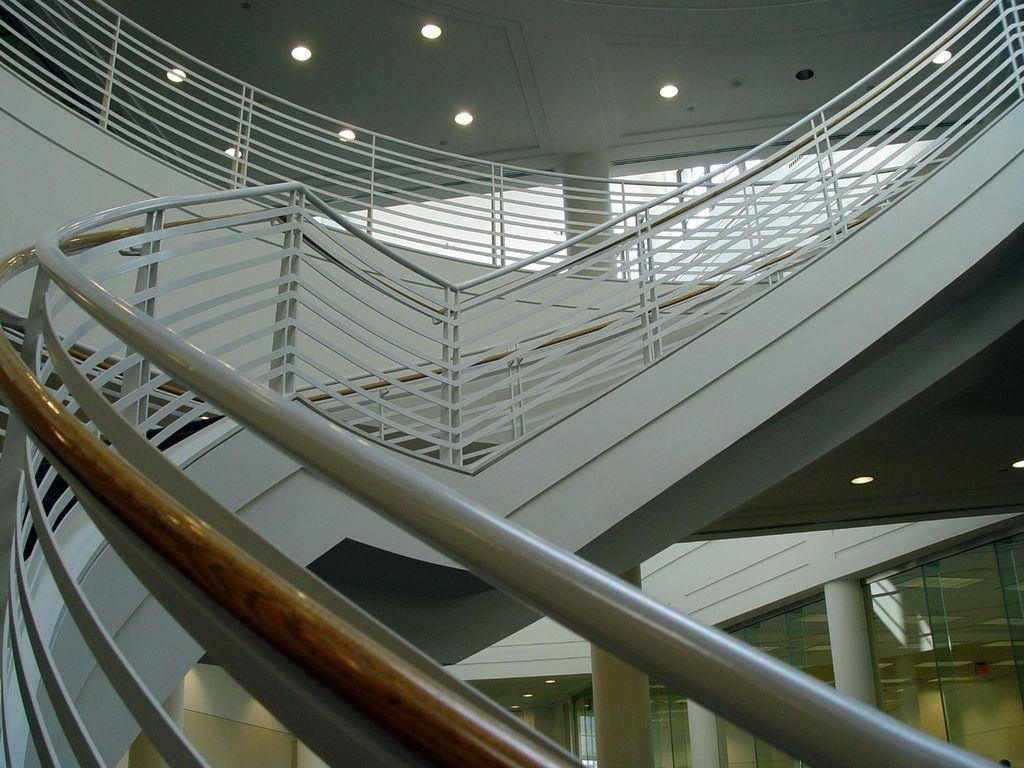What type of view is shown in the image? The image shows an inner view of a building. What can be seen on the ceiling of the building? There is a roof with lights in the image. What architectural elements support the structure in the image? Pillars are present in the image. What safety feature is visible in the image? There is a railing in the image. What type of wall is visible in the image? The glass wall is visible in the image. What type of yarn is being used in the image? There is no yarn present in the image. --- Facts: 1. There is a person in the image. 2. The person is wearing a hat. 3. The person is holding a book. 4. The person is sitting on a chair. 5. There is a table in the image. Absurd Topics: unicorn, parachute, grade Conversation: Who or what is the main subject in the image? The main subject in the image is a person. What is the person wearing in the image? The person is wearing a hat in the image. What is the person holding in the image? The person is holding a book in the image. What is the person doing in the image? The person is sitting on a chair in the image. What other objects can be seen in the image? There is a table in the image. Reasoning: Let's think step by step in order to produce the conversation. We start by identifying the main subject of the image, which is a person. Then, we describe specific details about the person, such as the hat they are wearing, the book they are holding, and the fact that they are sitting on a chair. We also mention the presence of a table in the image. Each question is designed to elicit a specific detail about the image that is known from the provided facts. Absurd Question/Answer: Can you see a unicorn in the image? No, there is no unicorn present in the image. 